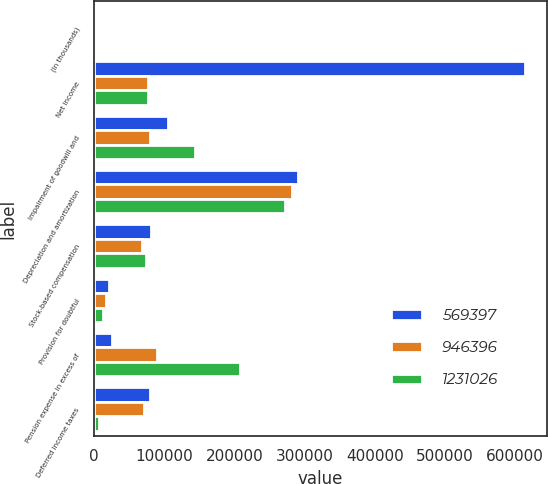<chart> <loc_0><loc_0><loc_500><loc_500><stacked_bar_chart><ecel><fcel>(In thousands)<fcel>Net income<fcel>Impairment of goodwill and<fcel>Depreciation and amortization<fcel>Stock-based compensation<fcel>Provision for doubtful<fcel>Pension expense in excess of<fcel>Deferred income taxes<nl><fcel>569397<fcel>2017<fcel>614923<fcel>104651<fcel>290503<fcel>81641<fcel>21171<fcel>25022<fcel>79838<nl><fcel>946396<fcel>2016<fcel>76532<fcel>79644<fcel>281577<fcel>67762<fcel>17283<fcel>89005<fcel>71625<nl><fcel>1.23103e+06<fcel>2015<fcel>76532<fcel>143562<fcel>272075<fcel>73420<fcel>12006<fcel>208709<fcel>7088<nl></chart> 